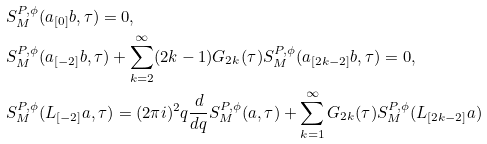Convert formula to latex. <formula><loc_0><loc_0><loc_500><loc_500>& S _ { M } ^ { P , \phi } ( a _ { [ 0 ] } b , \tau ) = 0 , \\ & S _ { M } ^ { P , \phi } ( a _ { [ - 2 ] } b , \tau ) + \sum _ { k = 2 } ^ { \infty } ( 2 k - 1 ) G _ { 2 k } ( \tau ) S _ { M } ^ { P , \phi } ( a _ { [ 2 k - 2 ] } b , \tau ) = 0 , \\ & S _ { M } ^ { P , \phi } ( L _ { [ - 2 ] } a , \tau ) = ( 2 \pi i ) ^ { 2 } q \frac { d } { d q } S _ { M } ^ { P , \phi } ( a , \tau ) + \sum _ { k = 1 } ^ { \infty } G _ { 2 k } ( \tau ) S _ { M } ^ { P , \phi } ( L _ { [ 2 k - 2 ] } a )</formula> 